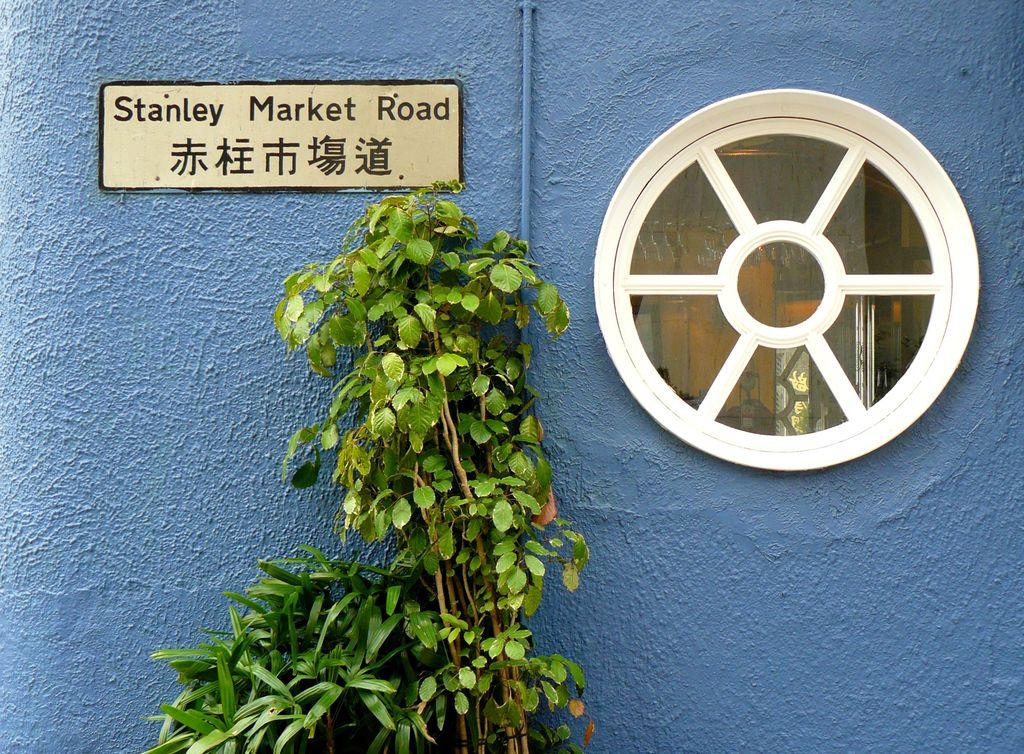What type of plant is visible in the image? There is a plant with leaves in the image. What is behind the plant in the image? There is a wall behind the plant. What is on the wall in the image? The wall has a board on it. What is written on the board in the image? There is text on the board. What type of window can be seen in the image? There is a round-shaped window in the image. What action is the pen performing in the image? There is no pen present in the image, so it cannot perform any actions. 